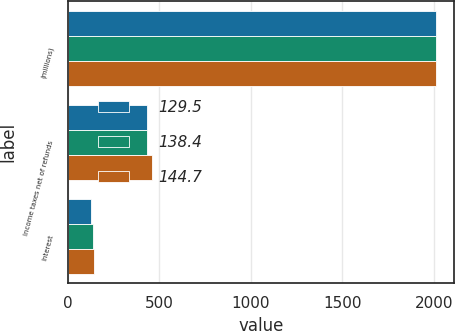Convert chart. <chart><loc_0><loc_0><loc_500><loc_500><stacked_bar_chart><ecel><fcel>(millions)<fcel>Income taxes net of refunds<fcel>Interest<nl><fcel>129.5<fcel>2011<fcel>435<fcel>129.5<nl><fcel>138.4<fcel>2010<fcel>434<fcel>138.4<nl><fcel>144.7<fcel>2009<fcel>461.7<fcel>144.7<nl></chart> 